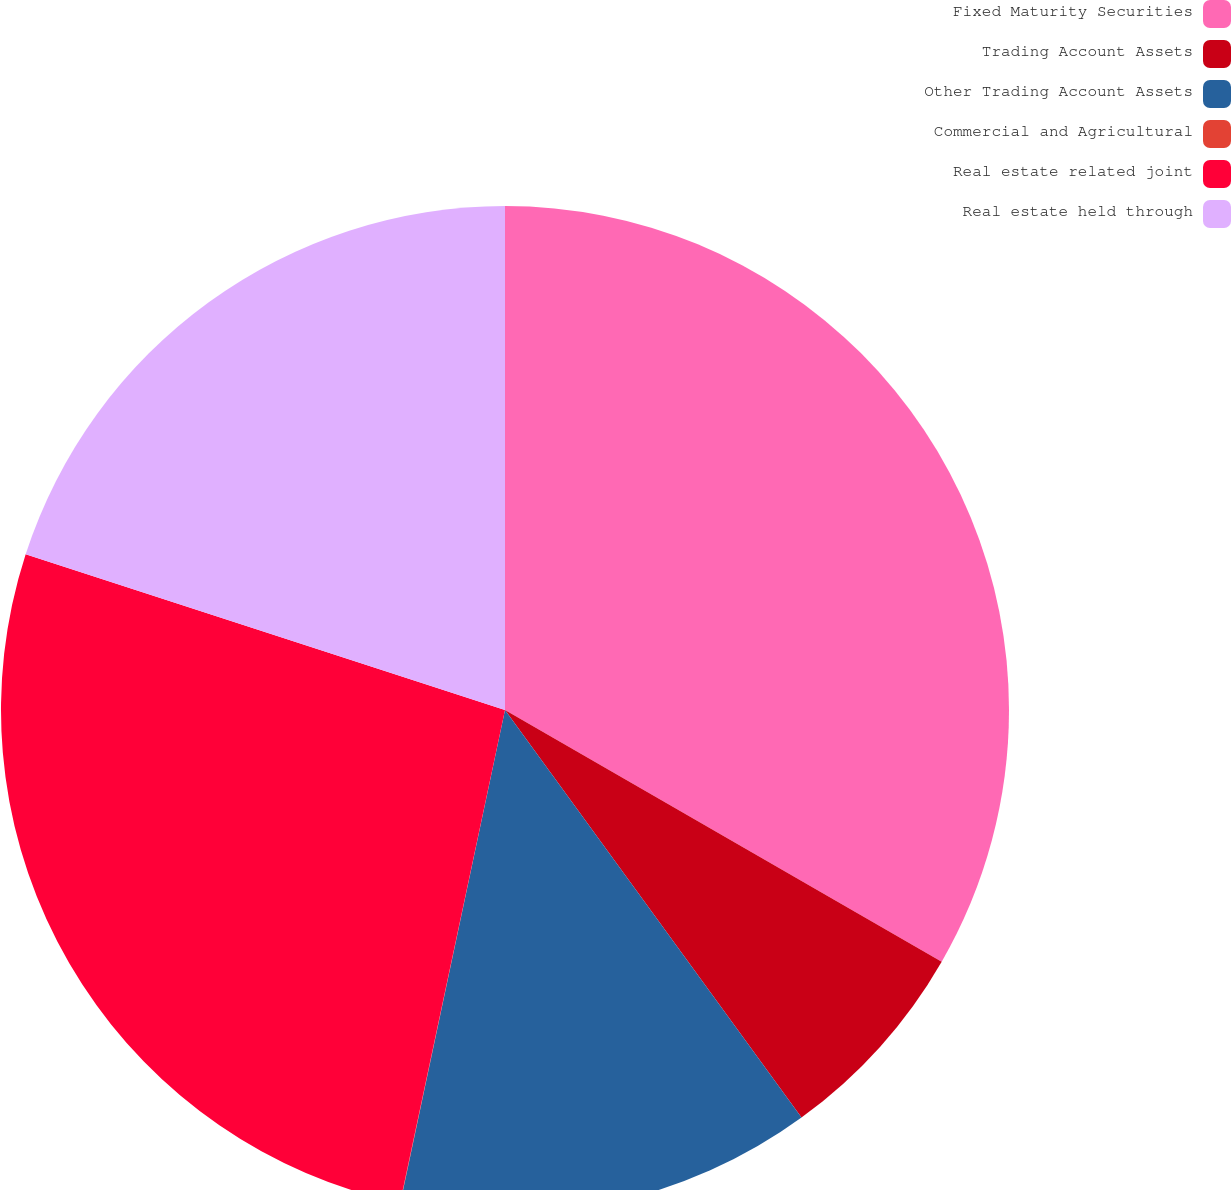Convert chart to OTSL. <chart><loc_0><loc_0><loc_500><loc_500><pie_chart><fcel>Fixed Maturity Securities<fcel>Trading Account Assets<fcel>Other Trading Account Assets<fcel>Commercial and Agricultural<fcel>Real estate related joint<fcel>Real estate held through<nl><fcel>33.32%<fcel>6.67%<fcel>13.34%<fcel>0.01%<fcel>26.66%<fcel>20.0%<nl></chart> 